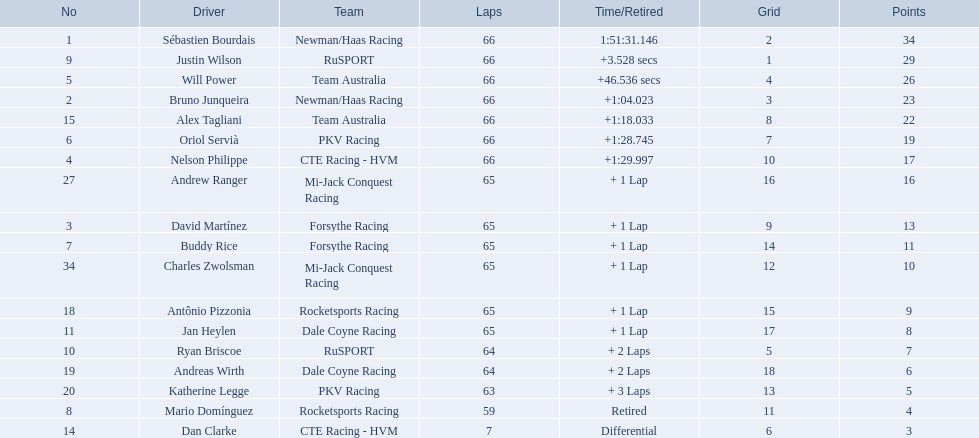What are the names of the drivers who were in position 14 through position 18? Ryan Briscoe, Andreas Wirth, Katherine Legge, Mario Domínguez, Dan Clarke. Of these , which ones didn't finish due to retired or differential? Mario Domínguez, Dan Clarke. Which one of the previous drivers retired? Mario Domínguez. Which of the drivers in question 2 had a differential? Dan Clarke. 